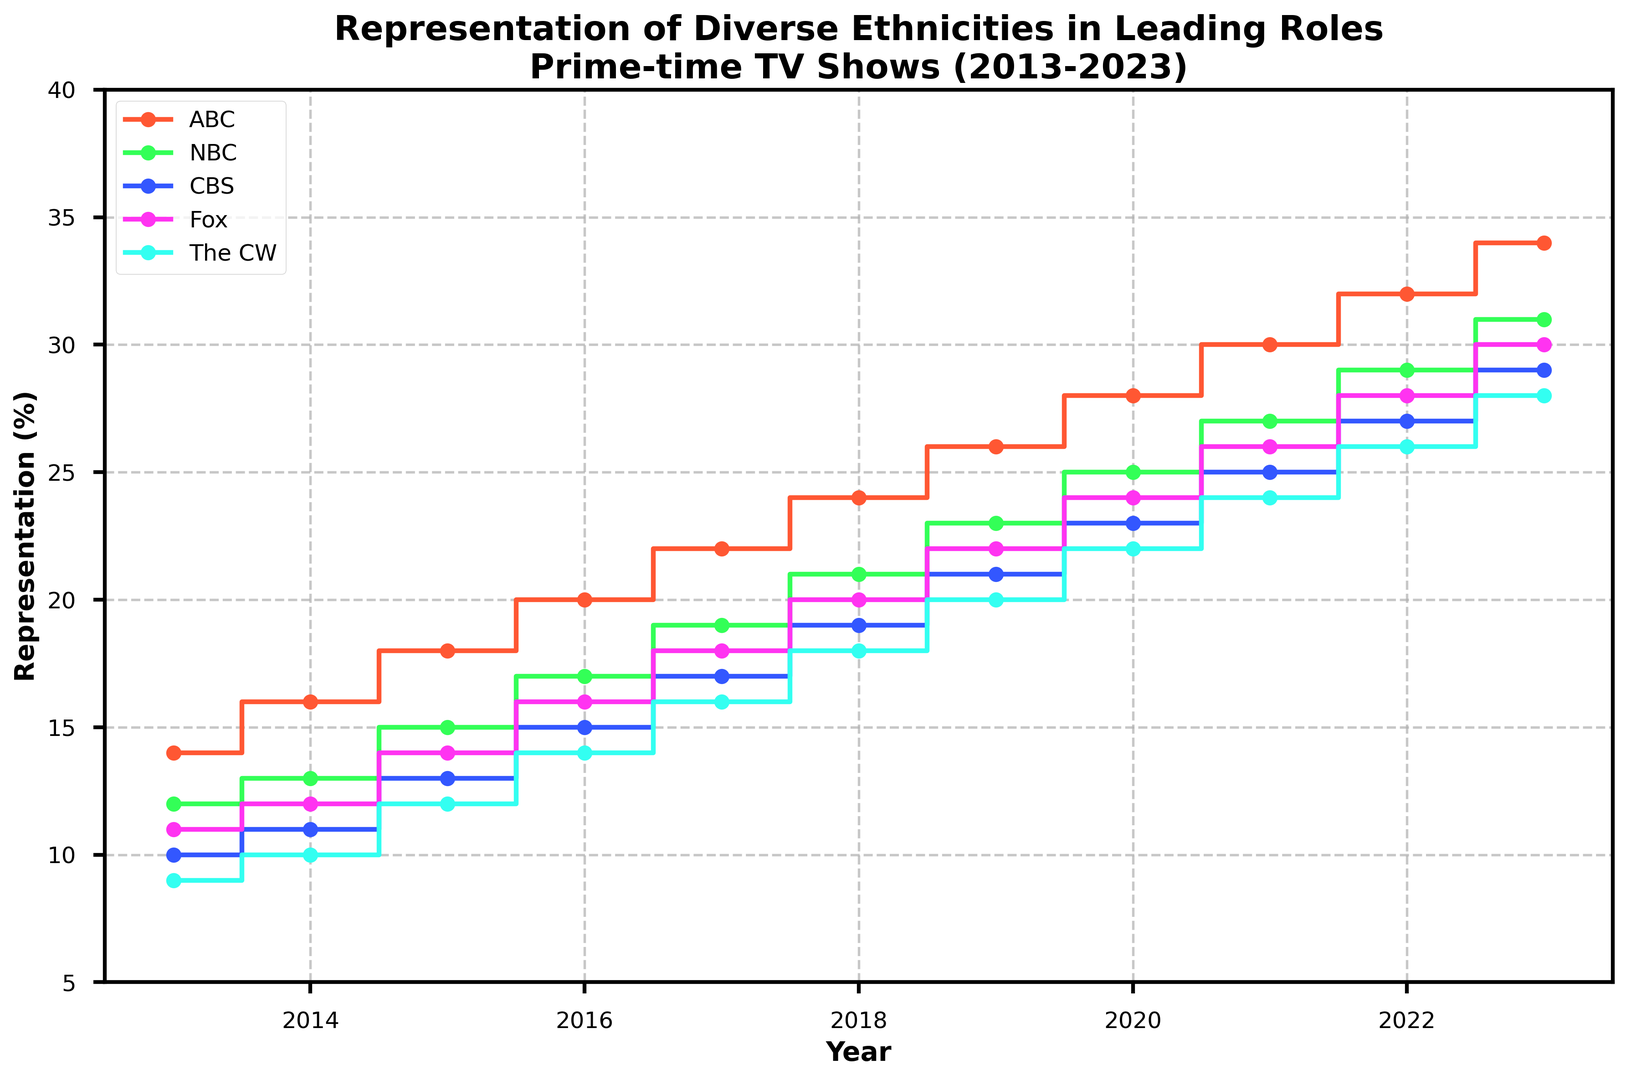Which network saw the greatest overall increase in representation between 2013 and 2023? To determine the network with the greatest increase, subtract the 2013 value from the 2023 value for each network: ABC (34-14=20), NBC (31-12=19), CBS (29-10=19), Fox (30-11=19), The CW (28-9=19). ABC saw the greatest increase, which is 20.
Answer: ABC In which year did ABC first exceed 20% representation? Check the values corresponding to ABC for each year to find when ABC first exceeds 20%. The year when ABC's representation first exceeds 20% is 2016 (20) when it reached exactly 20%.
Answer: 2016 How much lower was the representation in 2013 for The CW compared to NBC? Subtract The CW's 2013 value from NBC's 2013 value (12 - 9). NBC had 3 percentage points higher representation than The CW.
Answer: 3 Which network consistently had the lowest representation over the entire period? Compare the representations for each network across the entire period of 2013-2023. The CW consistently had the lowest representation every year.
Answer: The CW What is the average representation of diverse ethnicities for CBS over the 11 years? Add CBS representations from 2013 to 2023 and divide by the number of years: (10 + 11 + 13 + 15 + 17 + 19 + 21 + 23 + 25 + 27 + 29) / 11 = 20.6.
Answer: 20.6 Did any networks tie in their representation percent in any year? By examining the values, in no year do two networks have the same representation percent.
Answer: No Which network showed the second highest increase in representation from 2013 to 2023? After calculating the increases: ABC (20), NBC (19), CBS (19), Fox (19), The CW (19). All the other networks (NBC, CBS, Fox, The CW) showed the same second highest increase of 19.
Answer: NBC, CBS, Fox, The CW In 2020, how much higher was the representation for ABC compared to Fox? Subtract Fox's 2020 value from ABC's 2020 value (28-24). ABC had 4 percentage points higher representation than Fox.
Answer: 4 By how much did representation for diverse ethnicities increase from 2014 to 2018 for NBC? Subtract NBC's 2014 value from its 2018 value (21-13). The increase was 8 percentage points.
Answer: 8 Which year saw the highest combined representation among all networks, and what was that percentage? Add percentages for all networks for each year and compare. For 2023, the combined percentage is highest with (34 + 31 + 29 + 30 + 28 = 152). The year with the highest combined representation is 2023 with 152%.
Answer: 2023, 152 